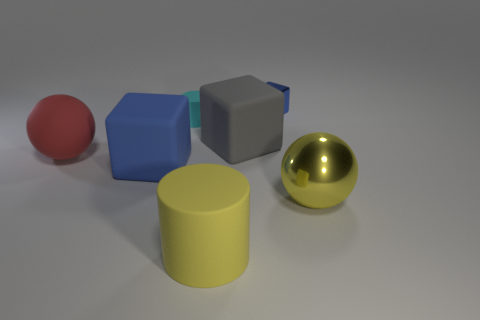Are there any other things of the same color as the small metallic block?
Make the answer very short. Yes. There is a rubber thing that is the same color as the metallic ball; what shape is it?
Offer a very short reply. Cylinder. There is a shiny sphere; is its color the same as the big rubber object that is in front of the blue rubber cube?
Your answer should be compact. Yes. Is the matte ball the same color as the metal block?
Offer a very short reply. No. What number of other things are there of the same material as the cyan object
Provide a succinct answer. 4. Are there the same number of large blue objects that are behind the tiny metal thing and tiny cyan matte cylinders?
Ensure brevity in your answer.  No. Do the yellow matte cylinder on the right side of the blue rubber thing and the big matte sphere have the same size?
Give a very brief answer. Yes. There is a gray matte thing; what number of gray rubber blocks are on the left side of it?
Your answer should be very brief. 0. There is a thing that is right of the big gray rubber object and in front of the tiny cyan matte thing; what material is it made of?
Offer a very short reply. Metal. What number of small objects are either red balls or blue rubber blocks?
Provide a succinct answer. 0. 